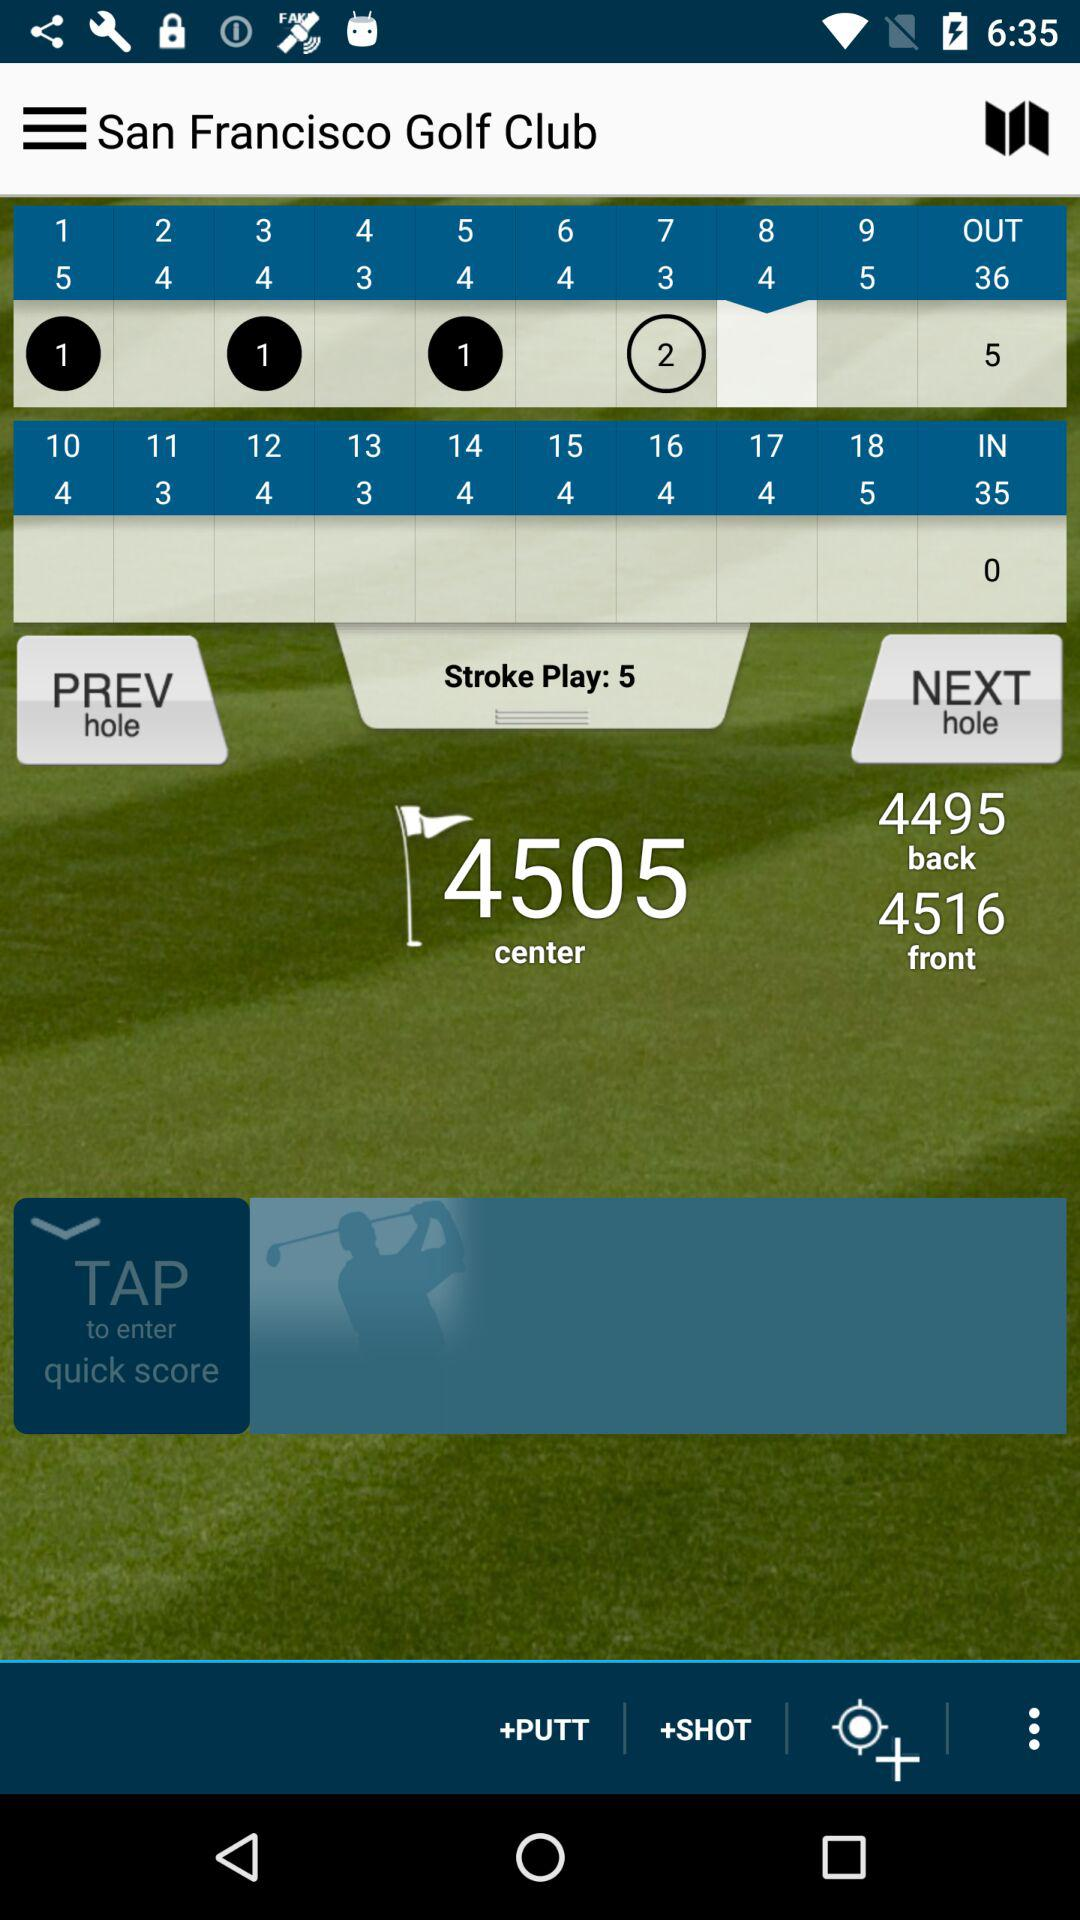What is the number of "IN"? The number of "IN" is 35. 